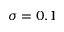Convert formula to latex. <formula><loc_0><loc_0><loc_500><loc_500>\sigma = 0 . 1</formula> 